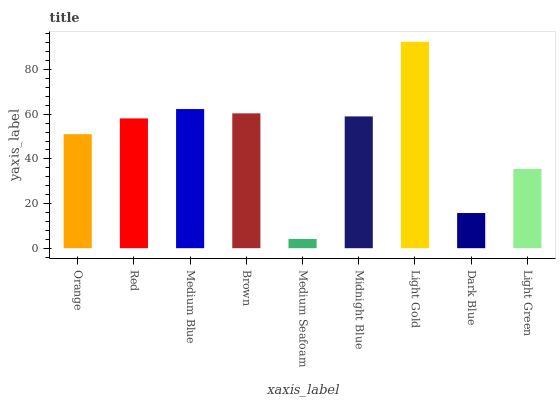Is Medium Seafoam the minimum?
Answer yes or no. Yes. Is Light Gold the maximum?
Answer yes or no. Yes. Is Red the minimum?
Answer yes or no. No. Is Red the maximum?
Answer yes or no. No. Is Red greater than Orange?
Answer yes or no. Yes. Is Orange less than Red?
Answer yes or no. Yes. Is Orange greater than Red?
Answer yes or no. No. Is Red less than Orange?
Answer yes or no. No. Is Red the high median?
Answer yes or no. Yes. Is Red the low median?
Answer yes or no. Yes. Is Light Gold the high median?
Answer yes or no. No. Is Light Green the low median?
Answer yes or no. No. 